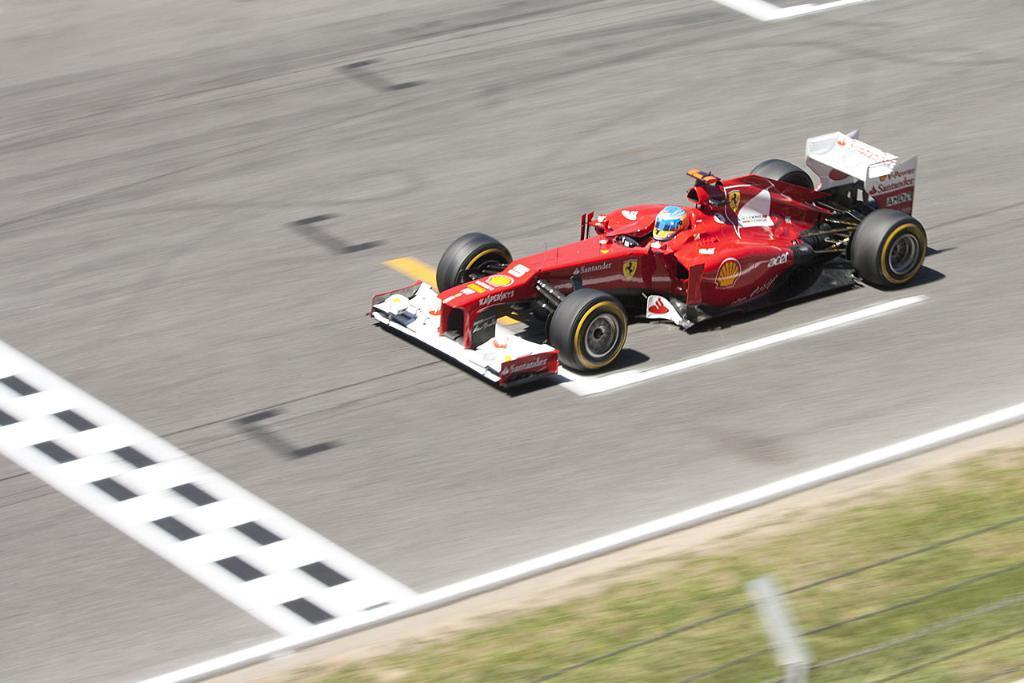How would you summarize this image in a sentence or two? In this picture we can see the wires and some grass on the ground. We can see a helmet and a car on the road. 